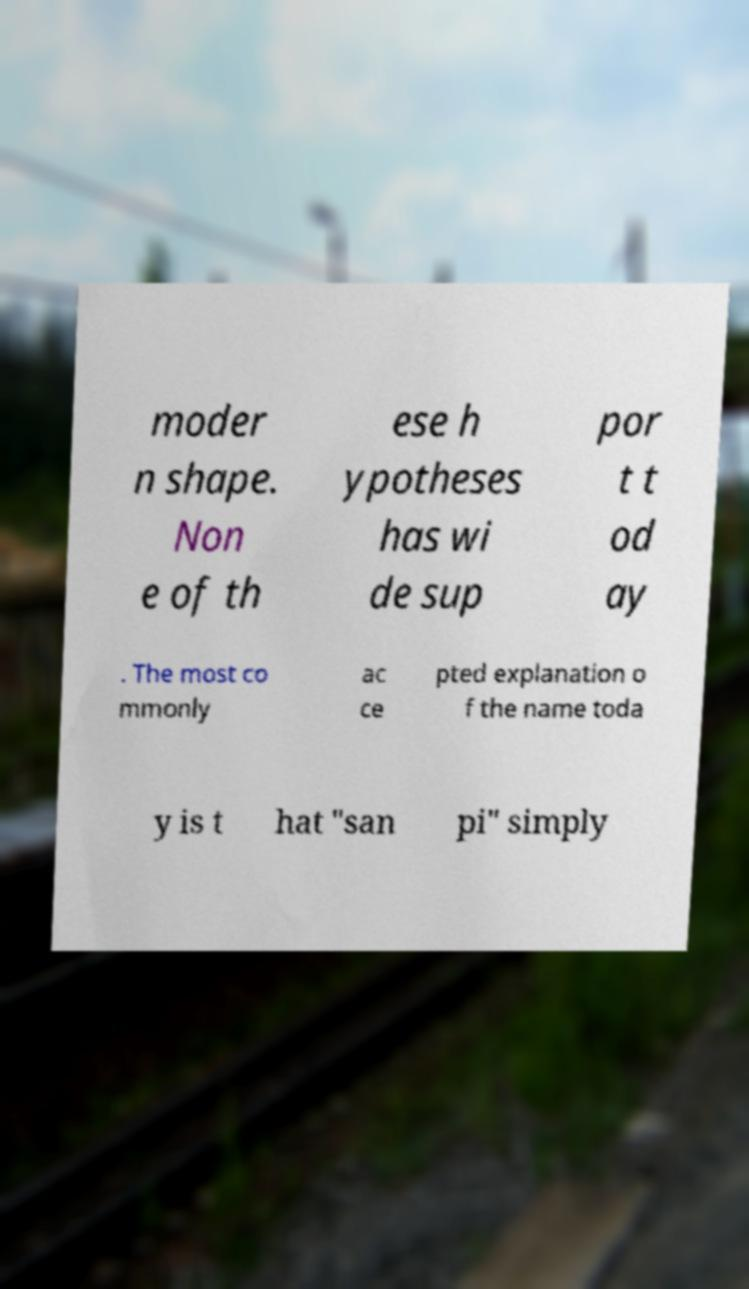There's text embedded in this image that I need extracted. Can you transcribe it verbatim? moder n shape. Non e of th ese h ypotheses has wi de sup por t t od ay . The most co mmonly ac ce pted explanation o f the name toda y is t hat "san pi" simply 